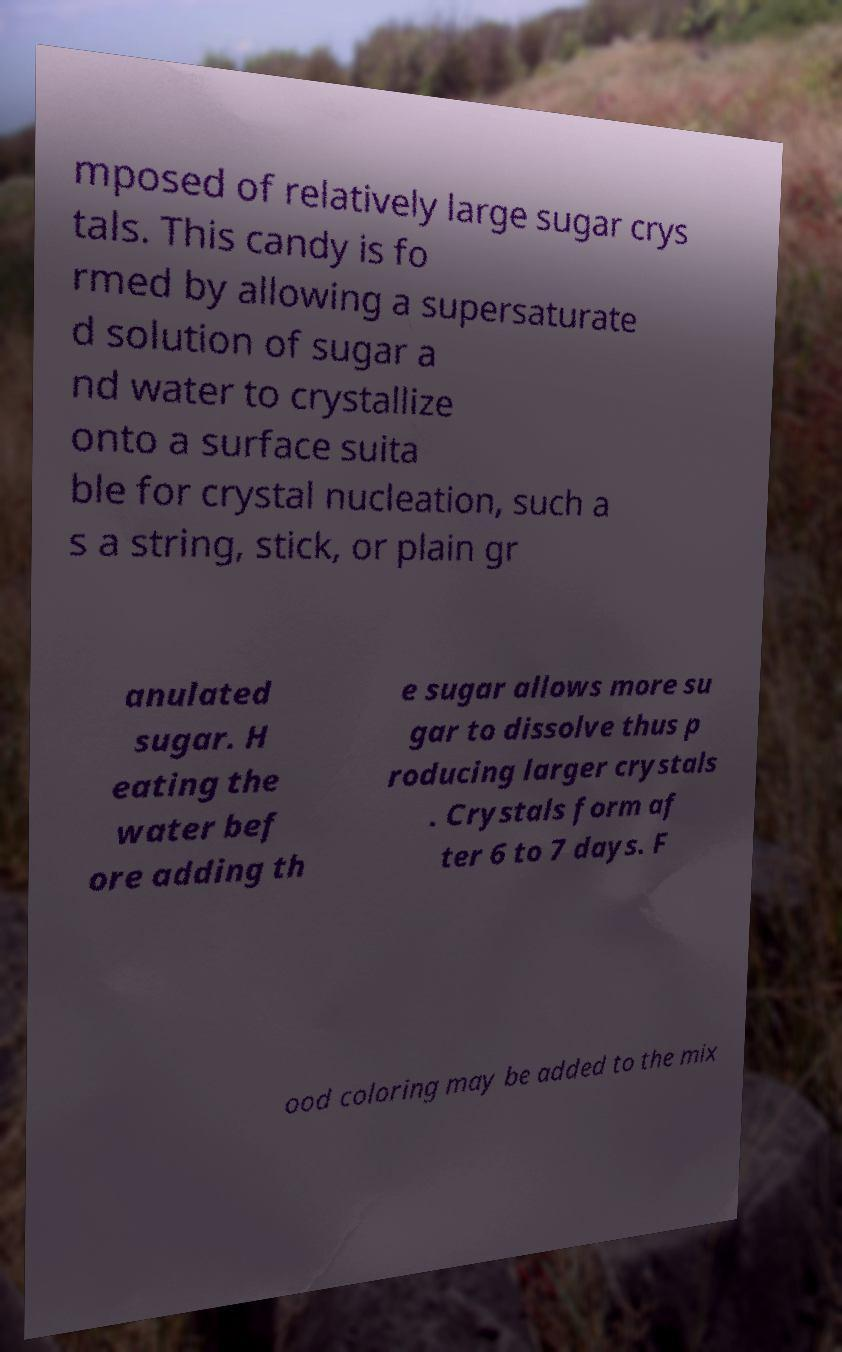Can you accurately transcribe the text from the provided image for me? mposed of relatively large sugar crys tals. This candy is fo rmed by allowing a supersaturate d solution of sugar a nd water to crystallize onto a surface suita ble for crystal nucleation, such a s a string, stick, or plain gr anulated sugar. H eating the water bef ore adding th e sugar allows more su gar to dissolve thus p roducing larger crystals . Crystals form af ter 6 to 7 days. F ood coloring may be added to the mix 